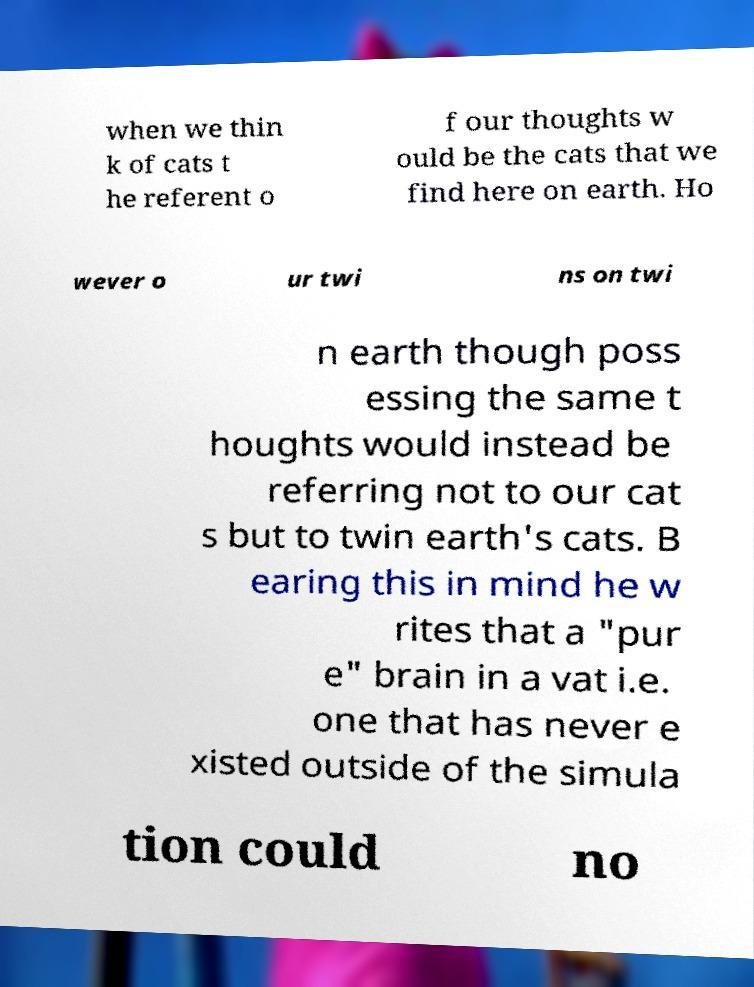Could you assist in decoding the text presented in this image and type it out clearly? when we thin k of cats t he referent o f our thoughts w ould be the cats that we find here on earth. Ho wever o ur twi ns on twi n earth though poss essing the same t houghts would instead be referring not to our cat s but to twin earth's cats. B earing this in mind he w rites that a "pur e" brain in a vat i.e. one that has never e xisted outside of the simula tion could no 